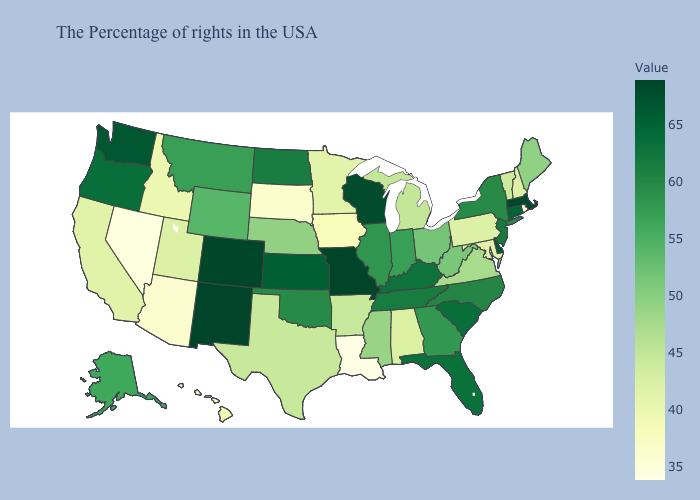Does Texas have a lower value than Louisiana?
Keep it brief. No. Which states have the lowest value in the USA?
Be succinct. Louisiana. Does Indiana have the highest value in the USA?
Be succinct. No. Which states hav the highest value in the Northeast?
Short answer required. Massachusetts. Which states have the lowest value in the MidWest?
Short answer required. South Dakota. Among the states that border South Dakota , which have the lowest value?
Answer briefly. Iowa. 